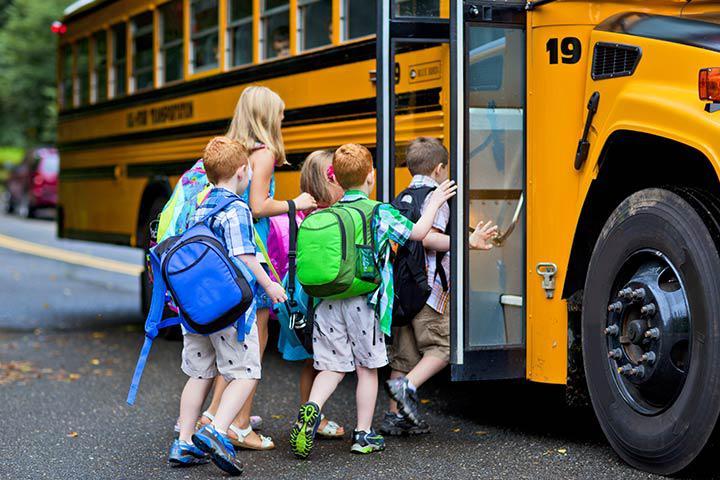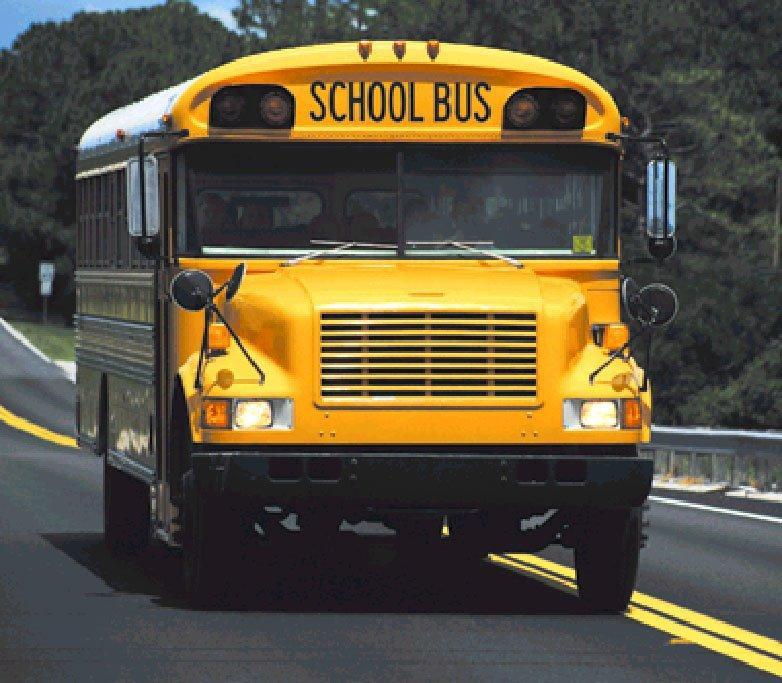The first image is the image on the left, the second image is the image on the right. Assess this claim about the two images: "One image in the pair shows a single school bus while the other shows at least three.". Correct or not? Answer yes or no. No. The first image is the image on the left, the second image is the image on the right. For the images displayed, is the sentence "One image shows the rear of a bright yellow school bus, including its emergency door and sets of red and amber lights on the top." factually correct? Answer yes or no. No. 